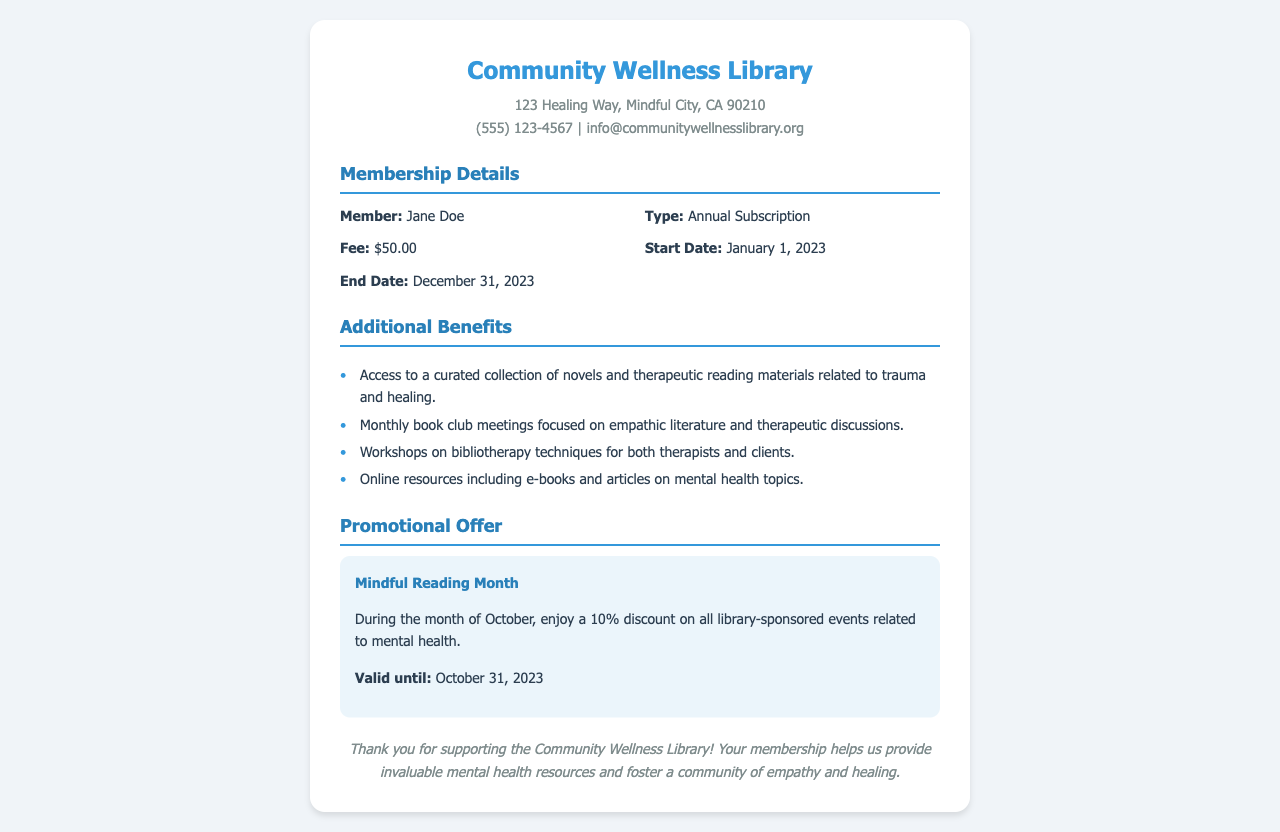What is the name of the library? The name of the library is stated clearly in the header section of the document.
Answer: Community Wellness Library What is the membership fee? The fee is mentioned under the membership details section of the document.
Answer: $50.00 When does the membership start? The start date is provided in the membership details section.
Answer: January 1, 2023 What benefits are included with the membership? The additional benefits list outlines various advantages provided to members.
Answer: Access to a curated collection of novels and therapeutic reading materials related to trauma and healing What is the discount available during Mindful Reading Month? The promotional offer section indicates the specifics of the discount during the event.
Answer: 10% What is the end date of the membership? The end date is specified in the membership details section of the document.
Answer: December 31, 2023 Who is the member listed on the receipt? The member's name is mentioned in the membership details section.
Answer: Jane Doe What are the monthly book club meetings focused on? The document describes the theme of these meetings in the benefits section.
Answer: Empathic literature and therapeutic discussions What is the validity date of the promotional offer? The validity of the promotional offer is provided in the promotional section.
Answer: October 31, 2023 